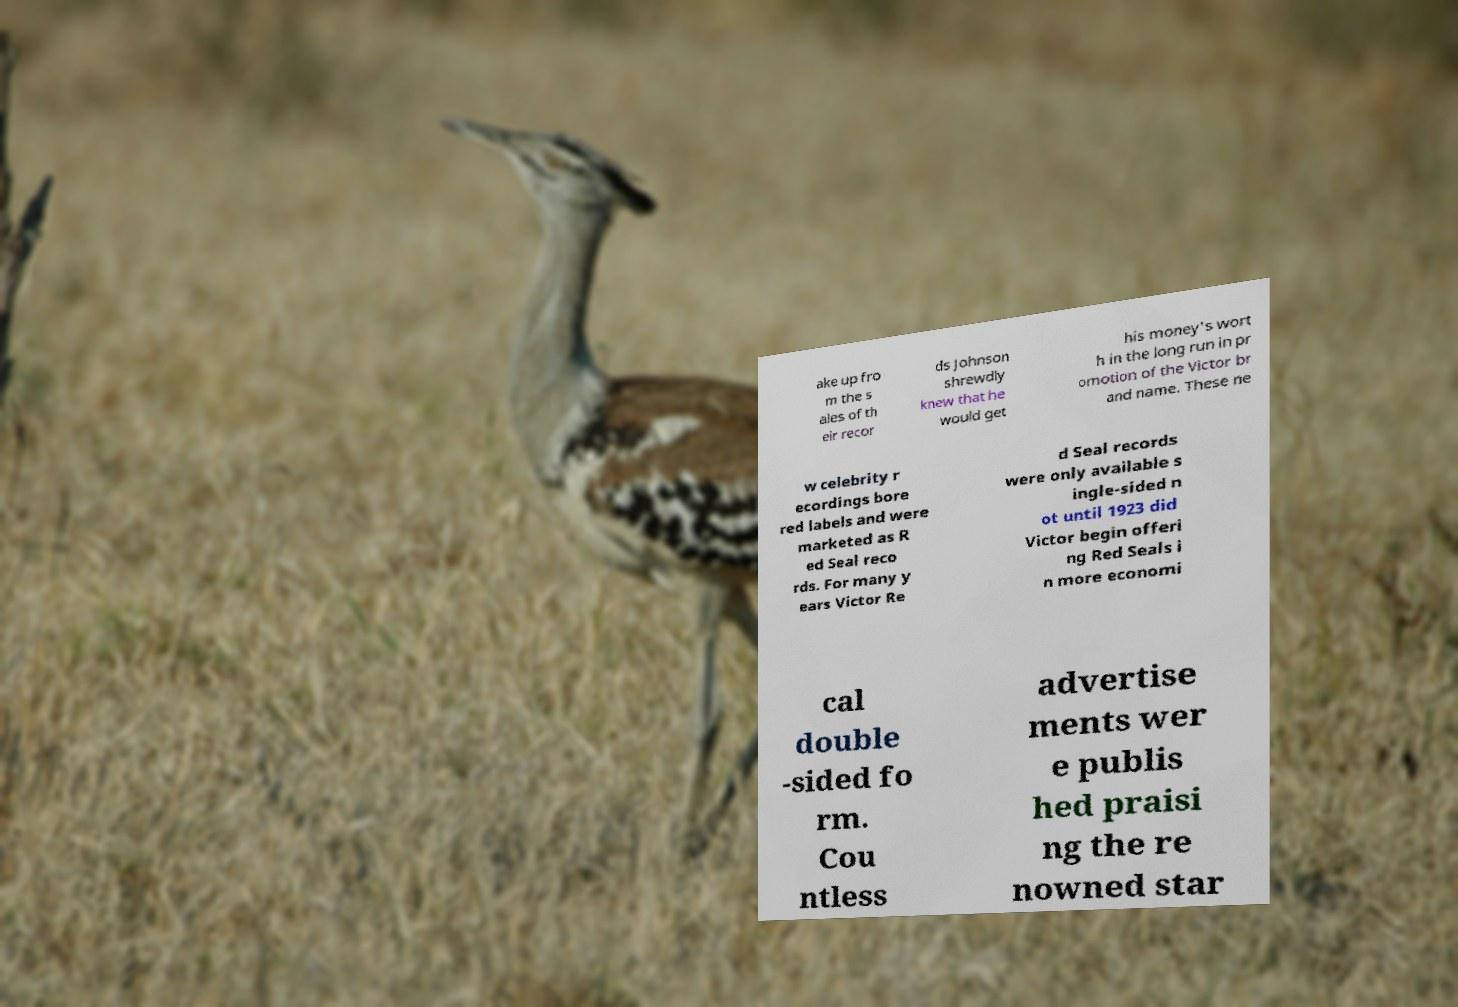Could you assist in decoding the text presented in this image and type it out clearly? ake up fro m the s ales of th eir recor ds Johnson shrewdly knew that he would get his money's wort h in the long run in pr omotion of the Victor br and name. These ne w celebrity r ecordings bore red labels and were marketed as R ed Seal reco rds. For many y ears Victor Re d Seal records were only available s ingle-sided n ot until 1923 did Victor begin offeri ng Red Seals i n more economi cal double -sided fo rm. Cou ntless advertise ments wer e publis hed praisi ng the re nowned star 